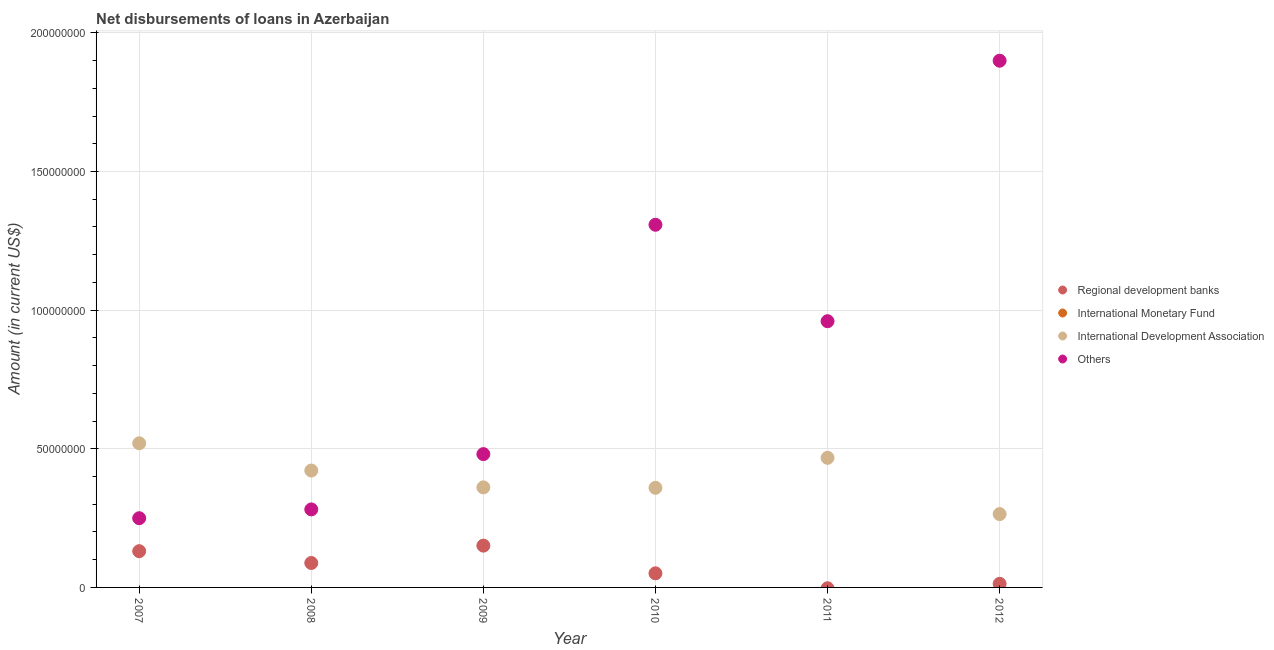What is the amount of loan disimbursed by international monetary fund in 2008?
Offer a very short reply. 0. Across all years, what is the maximum amount of loan disimbursed by regional development banks?
Ensure brevity in your answer.  1.51e+07. Across all years, what is the minimum amount of loan disimbursed by international development association?
Provide a short and direct response. 2.65e+07. In which year was the amount of loan disimbursed by international development association maximum?
Keep it short and to the point. 2007. What is the total amount of loan disimbursed by other organisations in the graph?
Your answer should be very brief. 5.18e+08. What is the difference between the amount of loan disimbursed by international development association in 2007 and that in 2009?
Provide a succinct answer. 1.59e+07. What is the difference between the amount of loan disimbursed by regional development banks in 2009 and the amount of loan disimbursed by international development association in 2008?
Offer a very short reply. -2.71e+07. What is the average amount of loan disimbursed by other organisations per year?
Give a very brief answer. 8.63e+07. In the year 2010, what is the difference between the amount of loan disimbursed by regional development banks and amount of loan disimbursed by other organisations?
Give a very brief answer. -1.26e+08. In how many years, is the amount of loan disimbursed by international monetary fund greater than 40000000 US$?
Offer a very short reply. 0. What is the ratio of the amount of loan disimbursed by international development association in 2011 to that in 2012?
Keep it short and to the point. 1.77. Is the amount of loan disimbursed by other organisations in 2010 less than that in 2011?
Offer a very short reply. No. Is the difference between the amount of loan disimbursed by other organisations in 2008 and 2009 greater than the difference between the amount of loan disimbursed by regional development banks in 2008 and 2009?
Your response must be concise. No. What is the difference between the highest and the second highest amount of loan disimbursed by international development association?
Your response must be concise. 5.24e+06. What is the difference between the highest and the lowest amount of loan disimbursed by other organisations?
Keep it short and to the point. 1.65e+08. Is the sum of the amount of loan disimbursed by regional development banks in 2008 and 2010 greater than the maximum amount of loan disimbursed by international development association across all years?
Ensure brevity in your answer.  No. Is it the case that in every year, the sum of the amount of loan disimbursed by international monetary fund and amount of loan disimbursed by other organisations is greater than the sum of amount of loan disimbursed by international development association and amount of loan disimbursed by regional development banks?
Offer a terse response. Yes. Is the amount of loan disimbursed by regional development banks strictly greater than the amount of loan disimbursed by international monetary fund over the years?
Ensure brevity in your answer.  Yes. Is the amount of loan disimbursed by international monetary fund strictly less than the amount of loan disimbursed by international development association over the years?
Your answer should be very brief. Yes. What is the difference between two consecutive major ticks on the Y-axis?
Your answer should be compact. 5.00e+07. Are the values on the major ticks of Y-axis written in scientific E-notation?
Make the answer very short. No. Does the graph contain grids?
Offer a very short reply. Yes. How many legend labels are there?
Your response must be concise. 4. What is the title of the graph?
Your answer should be very brief. Net disbursements of loans in Azerbaijan. Does "Tertiary education" appear as one of the legend labels in the graph?
Give a very brief answer. No. What is the label or title of the X-axis?
Keep it short and to the point. Year. What is the Amount (in current US$) of Regional development banks in 2007?
Your response must be concise. 1.31e+07. What is the Amount (in current US$) of International Development Association in 2007?
Provide a short and direct response. 5.20e+07. What is the Amount (in current US$) of Others in 2007?
Your answer should be very brief. 2.50e+07. What is the Amount (in current US$) in Regional development banks in 2008?
Your answer should be compact. 8.81e+06. What is the Amount (in current US$) of International Development Association in 2008?
Your answer should be compact. 4.22e+07. What is the Amount (in current US$) in Others in 2008?
Offer a very short reply. 2.81e+07. What is the Amount (in current US$) in Regional development banks in 2009?
Ensure brevity in your answer.  1.51e+07. What is the Amount (in current US$) in International Development Association in 2009?
Make the answer very short. 3.61e+07. What is the Amount (in current US$) of Others in 2009?
Offer a very short reply. 4.81e+07. What is the Amount (in current US$) in Regional development banks in 2010?
Provide a succinct answer. 5.08e+06. What is the Amount (in current US$) in International Monetary Fund in 2010?
Your response must be concise. 0. What is the Amount (in current US$) of International Development Association in 2010?
Offer a terse response. 3.59e+07. What is the Amount (in current US$) of Others in 2010?
Your answer should be compact. 1.31e+08. What is the Amount (in current US$) of Regional development banks in 2011?
Your response must be concise. 0. What is the Amount (in current US$) in International Development Association in 2011?
Offer a terse response. 4.67e+07. What is the Amount (in current US$) of Others in 2011?
Provide a succinct answer. 9.60e+07. What is the Amount (in current US$) of Regional development banks in 2012?
Offer a terse response. 1.30e+06. What is the Amount (in current US$) of International Monetary Fund in 2012?
Offer a very short reply. 0. What is the Amount (in current US$) in International Development Association in 2012?
Offer a terse response. 2.65e+07. What is the Amount (in current US$) of Others in 2012?
Provide a succinct answer. 1.90e+08. Across all years, what is the maximum Amount (in current US$) of Regional development banks?
Keep it short and to the point. 1.51e+07. Across all years, what is the maximum Amount (in current US$) in International Development Association?
Your answer should be compact. 5.20e+07. Across all years, what is the maximum Amount (in current US$) in Others?
Make the answer very short. 1.90e+08. Across all years, what is the minimum Amount (in current US$) in International Development Association?
Give a very brief answer. 2.65e+07. Across all years, what is the minimum Amount (in current US$) in Others?
Offer a very short reply. 2.50e+07. What is the total Amount (in current US$) of Regional development banks in the graph?
Your answer should be very brief. 4.33e+07. What is the total Amount (in current US$) of International Monetary Fund in the graph?
Your response must be concise. 0. What is the total Amount (in current US$) in International Development Association in the graph?
Keep it short and to the point. 2.39e+08. What is the total Amount (in current US$) in Others in the graph?
Provide a short and direct response. 5.18e+08. What is the difference between the Amount (in current US$) in Regional development banks in 2007 and that in 2008?
Keep it short and to the point. 4.26e+06. What is the difference between the Amount (in current US$) of International Development Association in 2007 and that in 2008?
Your answer should be compact. 9.82e+06. What is the difference between the Amount (in current US$) in Others in 2007 and that in 2008?
Give a very brief answer. -3.17e+06. What is the difference between the Amount (in current US$) of Regional development banks in 2007 and that in 2009?
Your response must be concise. -2.00e+06. What is the difference between the Amount (in current US$) in International Development Association in 2007 and that in 2009?
Keep it short and to the point. 1.59e+07. What is the difference between the Amount (in current US$) in Others in 2007 and that in 2009?
Make the answer very short. -2.31e+07. What is the difference between the Amount (in current US$) of Regional development banks in 2007 and that in 2010?
Ensure brevity in your answer.  7.98e+06. What is the difference between the Amount (in current US$) in International Development Association in 2007 and that in 2010?
Provide a short and direct response. 1.61e+07. What is the difference between the Amount (in current US$) of Others in 2007 and that in 2010?
Keep it short and to the point. -1.06e+08. What is the difference between the Amount (in current US$) of International Development Association in 2007 and that in 2011?
Provide a succinct answer. 5.24e+06. What is the difference between the Amount (in current US$) in Others in 2007 and that in 2011?
Your answer should be compact. -7.10e+07. What is the difference between the Amount (in current US$) of Regional development banks in 2007 and that in 2012?
Give a very brief answer. 1.18e+07. What is the difference between the Amount (in current US$) of International Development Association in 2007 and that in 2012?
Your answer should be compact. 2.55e+07. What is the difference between the Amount (in current US$) of Others in 2007 and that in 2012?
Your response must be concise. -1.65e+08. What is the difference between the Amount (in current US$) in Regional development banks in 2008 and that in 2009?
Your response must be concise. -6.26e+06. What is the difference between the Amount (in current US$) of International Development Association in 2008 and that in 2009?
Provide a short and direct response. 6.08e+06. What is the difference between the Amount (in current US$) in Others in 2008 and that in 2009?
Your answer should be very brief. -1.99e+07. What is the difference between the Amount (in current US$) in Regional development banks in 2008 and that in 2010?
Give a very brief answer. 3.73e+06. What is the difference between the Amount (in current US$) in International Development Association in 2008 and that in 2010?
Give a very brief answer. 6.23e+06. What is the difference between the Amount (in current US$) of Others in 2008 and that in 2010?
Offer a terse response. -1.03e+08. What is the difference between the Amount (in current US$) of International Development Association in 2008 and that in 2011?
Keep it short and to the point. -4.58e+06. What is the difference between the Amount (in current US$) in Others in 2008 and that in 2011?
Your response must be concise. -6.79e+07. What is the difference between the Amount (in current US$) in Regional development banks in 2008 and that in 2012?
Provide a succinct answer. 7.52e+06. What is the difference between the Amount (in current US$) in International Development Association in 2008 and that in 2012?
Give a very brief answer. 1.57e+07. What is the difference between the Amount (in current US$) in Others in 2008 and that in 2012?
Provide a succinct answer. -1.62e+08. What is the difference between the Amount (in current US$) of Regional development banks in 2009 and that in 2010?
Make the answer very short. 9.99e+06. What is the difference between the Amount (in current US$) of International Development Association in 2009 and that in 2010?
Your answer should be compact. 1.56e+05. What is the difference between the Amount (in current US$) in Others in 2009 and that in 2010?
Keep it short and to the point. -8.27e+07. What is the difference between the Amount (in current US$) of International Development Association in 2009 and that in 2011?
Offer a terse response. -1.07e+07. What is the difference between the Amount (in current US$) in Others in 2009 and that in 2011?
Ensure brevity in your answer.  -4.79e+07. What is the difference between the Amount (in current US$) in Regional development banks in 2009 and that in 2012?
Offer a terse response. 1.38e+07. What is the difference between the Amount (in current US$) of International Development Association in 2009 and that in 2012?
Make the answer very short. 9.63e+06. What is the difference between the Amount (in current US$) of Others in 2009 and that in 2012?
Provide a short and direct response. -1.42e+08. What is the difference between the Amount (in current US$) of International Development Association in 2010 and that in 2011?
Give a very brief answer. -1.08e+07. What is the difference between the Amount (in current US$) in Others in 2010 and that in 2011?
Keep it short and to the point. 3.48e+07. What is the difference between the Amount (in current US$) in Regional development banks in 2010 and that in 2012?
Your response must be concise. 3.79e+06. What is the difference between the Amount (in current US$) in International Development Association in 2010 and that in 2012?
Provide a succinct answer. 9.47e+06. What is the difference between the Amount (in current US$) in Others in 2010 and that in 2012?
Keep it short and to the point. -5.92e+07. What is the difference between the Amount (in current US$) of International Development Association in 2011 and that in 2012?
Offer a terse response. 2.03e+07. What is the difference between the Amount (in current US$) of Others in 2011 and that in 2012?
Provide a succinct answer. -9.39e+07. What is the difference between the Amount (in current US$) of Regional development banks in 2007 and the Amount (in current US$) of International Development Association in 2008?
Keep it short and to the point. -2.91e+07. What is the difference between the Amount (in current US$) in Regional development banks in 2007 and the Amount (in current US$) in Others in 2008?
Offer a terse response. -1.51e+07. What is the difference between the Amount (in current US$) of International Development Association in 2007 and the Amount (in current US$) of Others in 2008?
Ensure brevity in your answer.  2.38e+07. What is the difference between the Amount (in current US$) in Regional development banks in 2007 and the Amount (in current US$) in International Development Association in 2009?
Provide a short and direct response. -2.30e+07. What is the difference between the Amount (in current US$) of Regional development banks in 2007 and the Amount (in current US$) of Others in 2009?
Keep it short and to the point. -3.50e+07. What is the difference between the Amount (in current US$) of International Development Association in 2007 and the Amount (in current US$) of Others in 2009?
Provide a succinct answer. 3.90e+06. What is the difference between the Amount (in current US$) in Regional development banks in 2007 and the Amount (in current US$) in International Development Association in 2010?
Your answer should be very brief. -2.29e+07. What is the difference between the Amount (in current US$) in Regional development banks in 2007 and the Amount (in current US$) in Others in 2010?
Make the answer very short. -1.18e+08. What is the difference between the Amount (in current US$) in International Development Association in 2007 and the Amount (in current US$) in Others in 2010?
Provide a succinct answer. -7.88e+07. What is the difference between the Amount (in current US$) of Regional development banks in 2007 and the Amount (in current US$) of International Development Association in 2011?
Your answer should be very brief. -3.37e+07. What is the difference between the Amount (in current US$) in Regional development banks in 2007 and the Amount (in current US$) in Others in 2011?
Make the answer very short. -8.29e+07. What is the difference between the Amount (in current US$) in International Development Association in 2007 and the Amount (in current US$) in Others in 2011?
Provide a succinct answer. -4.40e+07. What is the difference between the Amount (in current US$) of Regional development banks in 2007 and the Amount (in current US$) of International Development Association in 2012?
Ensure brevity in your answer.  -1.34e+07. What is the difference between the Amount (in current US$) of Regional development banks in 2007 and the Amount (in current US$) of Others in 2012?
Provide a short and direct response. -1.77e+08. What is the difference between the Amount (in current US$) of International Development Association in 2007 and the Amount (in current US$) of Others in 2012?
Provide a short and direct response. -1.38e+08. What is the difference between the Amount (in current US$) in Regional development banks in 2008 and the Amount (in current US$) in International Development Association in 2009?
Provide a succinct answer. -2.73e+07. What is the difference between the Amount (in current US$) of Regional development banks in 2008 and the Amount (in current US$) of Others in 2009?
Keep it short and to the point. -3.93e+07. What is the difference between the Amount (in current US$) of International Development Association in 2008 and the Amount (in current US$) of Others in 2009?
Give a very brief answer. -5.92e+06. What is the difference between the Amount (in current US$) of Regional development banks in 2008 and the Amount (in current US$) of International Development Association in 2010?
Your answer should be very brief. -2.71e+07. What is the difference between the Amount (in current US$) of Regional development banks in 2008 and the Amount (in current US$) of Others in 2010?
Offer a terse response. -1.22e+08. What is the difference between the Amount (in current US$) of International Development Association in 2008 and the Amount (in current US$) of Others in 2010?
Your answer should be compact. -8.86e+07. What is the difference between the Amount (in current US$) in Regional development banks in 2008 and the Amount (in current US$) in International Development Association in 2011?
Ensure brevity in your answer.  -3.79e+07. What is the difference between the Amount (in current US$) of Regional development banks in 2008 and the Amount (in current US$) of Others in 2011?
Your answer should be compact. -8.72e+07. What is the difference between the Amount (in current US$) of International Development Association in 2008 and the Amount (in current US$) of Others in 2011?
Ensure brevity in your answer.  -5.39e+07. What is the difference between the Amount (in current US$) in Regional development banks in 2008 and the Amount (in current US$) in International Development Association in 2012?
Your answer should be very brief. -1.76e+07. What is the difference between the Amount (in current US$) of Regional development banks in 2008 and the Amount (in current US$) of Others in 2012?
Keep it short and to the point. -1.81e+08. What is the difference between the Amount (in current US$) of International Development Association in 2008 and the Amount (in current US$) of Others in 2012?
Offer a very short reply. -1.48e+08. What is the difference between the Amount (in current US$) in Regional development banks in 2009 and the Amount (in current US$) in International Development Association in 2010?
Keep it short and to the point. -2.09e+07. What is the difference between the Amount (in current US$) in Regional development banks in 2009 and the Amount (in current US$) in Others in 2010?
Your response must be concise. -1.16e+08. What is the difference between the Amount (in current US$) of International Development Association in 2009 and the Amount (in current US$) of Others in 2010?
Give a very brief answer. -9.47e+07. What is the difference between the Amount (in current US$) in Regional development banks in 2009 and the Amount (in current US$) in International Development Association in 2011?
Ensure brevity in your answer.  -3.17e+07. What is the difference between the Amount (in current US$) in Regional development banks in 2009 and the Amount (in current US$) in Others in 2011?
Ensure brevity in your answer.  -8.09e+07. What is the difference between the Amount (in current US$) of International Development Association in 2009 and the Amount (in current US$) of Others in 2011?
Make the answer very short. -5.99e+07. What is the difference between the Amount (in current US$) in Regional development banks in 2009 and the Amount (in current US$) in International Development Association in 2012?
Provide a short and direct response. -1.14e+07. What is the difference between the Amount (in current US$) in Regional development banks in 2009 and the Amount (in current US$) in Others in 2012?
Provide a short and direct response. -1.75e+08. What is the difference between the Amount (in current US$) of International Development Association in 2009 and the Amount (in current US$) of Others in 2012?
Your answer should be compact. -1.54e+08. What is the difference between the Amount (in current US$) in Regional development banks in 2010 and the Amount (in current US$) in International Development Association in 2011?
Give a very brief answer. -4.17e+07. What is the difference between the Amount (in current US$) in Regional development banks in 2010 and the Amount (in current US$) in Others in 2011?
Provide a succinct answer. -9.09e+07. What is the difference between the Amount (in current US$) of International Development Association in 2010 and the Amount (in current US$) of Others in 2011?
Your response must be concise. -6.01e+07. What is the difference between the Amount (in current US$) in Regional development banks in 2010 and the Amount (in current US$) in International Development Association in 2012?
Keep it short and to the point. -2.14e+07. What is the difference between the Amount (in current US$) of Regional development banks in 2010 and the Amount (in current US$) of Others in 2012?
Your answer should be very brief. -1.85e+08. What is the difference between the Amount (in current US$) in International Development Association in 2010 and the Amount (in current US$) in Others in 2012?
Your answer should be very brief. -1.54e+08. What is the difference between the Amount (in current US$) in International Development Association in 2011 and the Amount (in current US$) in Others in 2012?
Your answer should be very brief. -1.43e+08. What is the average Amount (in current US$) in Regional development banks per year?
Your answer should be compact. 7.22e+06. What is the average Amount (in current US$) of International Monetary Fund per year?
Your response must be concise. 0. What is the average Amount (in current US$) in International Development Association per year?
Offer a very short reply. 3.99e+07. What is the average Amount (in current US$) in Others per year?
Provide a short and direct response. 8.63e+07. In the year 2007, what is the difference between the Amount (in current US$) of Regional development banks and Amount (in current US$) of International Development Association?
Give a very brief answer. -3.89e+07. In the year 2007, what is the difference between the Amount (in current US$) in Regional development banks and Amount (in current US$) in Others?
Your answer should be very brief. -1.19e+07. In the year 2007, what is the difference between the Amount (in current US$) of International Development Association and Amount (in current US$) of Others?
Provide a short and direct response. 2.70e+07. In the year 2008, what is the difference between the Amount (in current US$) of Regional development banks and Amount (in current US$) of International Development Association?
Keep it short and to the point. -3.33e+07. In the year 2008, what is the difference between the Amount (in current US$) in Regional development banks and Amount (in current US$) in Others?
Your answer should be very brief. -1.93e+07. In the year 2008, what is the difference between the Amount (in current US$) of International Development Association and Amount (in current US$) of Others?
Offer a terse response. 1.40e+07. In the year 2009, what is the difference between the Amount (in current US$) in Regional development banks and Amount (in current US$) in International Development Association?
Provide a short and direct response. -2.10e+07. In the year 2009, what is the difference between the Amount (in current US$) of Regional development banks and Amount (in current US$) of Others?
Your answer should be compact. -3.30e+07. In the year 2009, what is the difference between the Amount (in current US$) of International Development Association and Amount (in current US$) of Others?
Make the answer very short. -1.20e+07. In the year 2010, what is the difference between the Amount (in current US$) of Regional development banks and Amount (in current US$) of International Development Association?
Your response must be concise. -3.08e+07. In the year 2010, what is the difference between the Amount (in current US$) of Regional development banks and Amount (in current US$) of Others?
Provide a succinct answer. -1.26e+08. In the year 2010, what is the difference between the Amount (in current US$) of International Development Association and Amount (in current US$) of Others?
Your response must be concise. -9.49e+07. In the year 2011, what is the difference between the Amount (in current US$) of International Development Association and Amount (in current US$) of Others?
Offer a very short reply. -4.93e+07. In the year 2012, what is the difference between the Amount (in current US$) in Regional development banks and Amount (in current US$) in International Development Association?
Your answer should be compact. -2.52e+07. In the year 2012, what is the difference between the Amount (in current US$) of Regional development banks and Amount (in current US$) of Others?
Give a very brief answer. -1.89e+08. In the year 2012, what is the difference between the Amount (in current US$) of International Development Association and Amount (in current US$) of Others?
Make the answer very short. -1.64e+08. What is the ratio of the Amount (in current US$) in Regional development banks in 2007 to that in 2008?
Provide a short and direct response. 1.48. What is the ratio of the Amount (in current US$) of International Development Association in 2007 to that in 2008?
Your answer should be compact. 1.23. What is the ratio of the Amount (in current US$) of Others in 2007 to that in 2008?
Provide a short and direct response. 0.89. What is the ratio of the Amount (in current US$) in Regional development banks in 2007 to that in 2009?
Provide a short and direct response. 0.87. What is the ratio of the Amount (in current US$) of International Development Association in 2007 to that in 2009?
Your answer should be very brief. 1.44. What is the ratio of the Amount (in current US$) in Others in 2007 to that in 2009?
Ensure brevity in your answer.  0.52. What is the ratio of the Amount (in current US$) in Regional development banks in 2007 to that in 2010?
Your answer should be very brief. 2.57. What is the ratio of the Amount (in current US$) in International Development Association in 2007 to that in 2010?
Provide a short and direct response. 1.45. What is the ratio of the Amount (in current US$) in Others in 2007 to that in 2010?
Ensure brevity in your answer.  0.19. What is the ratio of the Amount (in current US$) of International Development Association in 2007 to that in 2011?
Ensure brevity in your answer.  1.11. What is the ratio of the Amount (in current US$) in Others in 2007 to that in 2011?
Ensure brevity in your answer.  0.26. What is the ratio of the Amount (in current US$) in Regional development banks in 2007 to that in 2012?
Offer a very short reply. 10.08. What is the ratio of the Amount (in current US$) in International Development Association in 2007 to that in 2012?
Give a very brief answer. 1.97. What is the ratio of the Amount (in current US$) in Others in 2007 to that in 2012?
Ensure brevity in your answer.  0.13. What is the ratio of the Amount (in current US$) of Regional development banks in 2008 to that in 2009?
Provide a short and direct response. 0.58. What is the ratio of the Amount (in current US$) in International Development Association in 2008 to that in 2009?
Keep it short and to the point. 1.17. What is the ratio of the Amount (in current US$) in Others in 2008 to that in 2009?
Keep it short and to the point. 0.59. What is the ratio of the Amount (in current US$) in Regional development banks in 2008 to that in 2010?
Ensure brevity in your answer.  1.73. What is the ratio of the Amount (in current US$) in International Development Association in 2008 to that in 2010?
Ensure brevity in your answer.  1.17. What is the ratio of the Amount (in current US$) in Others in 2008 to that in 2010?
Your answer should be very brief. 0.22. What is the ratio of the Amount (in current US$) in International Development Association in 2008 to that in 2011?
Your answer should be compact. 0.9. What is the ratio of the Amount (in current US$) of Others in 2008 to that in 2011?
Make the answer very short. 0.29. What is the ratio of the Amount (in current US$) in Regional development banks in 2008 to that in 2012?
Provide a succinct answer. 6.8. What is the ratio of the Amount (in current US$) of International Development Association in 2008 to that in 2012?
Offer a terse response. 1.59. What is the ratio of the Amount (in current US$) in Others in 2008 to that in 2012?
Your response must be concise. 0.15. What is the ratio of the Amount (in current US$) of Regional development banks in 2009 to that in 2010?
Make the answer very short. 2.96. What is the ratio of the Amount (in current US$) in International Development Association in 2009 to that in 2010?
Keep it short and to the point. 1. What is the ratio of the Amount (in current US$) in Others in 2009 to that in 2010?
Make the answer very short. 0.37. What is the ratio of the Amount (in current US$) of International Development Association in 2009 to that in 2011?
Provide a short and direct response. 0.77. What is the ratio of the Amount (in current US$) of Others in 2009 to that in 2011?
Provide a succinct answer. 0.5. What is the ratio of the Amount (in current US$) of Regional development banks in 2009 to that in 2012?
Your answer should be compact. 11.62. What is the ratio of the Amount (in current US$) of International Development Association in 2009 to that in 2012?
Provide a succinct answer. 1.36. What is the ratio of the Amount (in current US$) in Others in 2009 to that in 2012?
Keep it short and to the point. 0.25. What is the ratio of the Amount (in current US$) in International Development Association in 2010 to that in 2011?
Provide a short and direct response. 0.77. What is the ratio of the Amount (in current US$) of Others in 2010 to that in 2011?
Your answer should be compact. 1.36. What is the ratio of the Amount (in current US$) in Regional development banks in 2010 to that in 2012?
Provide a succinct answer. 3.92. What is the ratio of the Amount (in current US$) in International Development Association in 2010 to that in 2012?
Ensure brevity in your answer.  1.36. What is the ratio of the Amount (in current US$) in Others in 2010 to that in 2012?
Offer a very short reply. 0.69. What is the ratio of the Amount (in current US$) in International Development Association in 2011 to that in 2012?
Provide a succinct answer. 1.77. What is the ratio of the Amount (in current US$) of Others in 2011 to that in 2012?
Offer a terse response. 0.51. What is the difference between the highest and the second highest Amount (in current US$) of Regional development banks?
Offer a very short reply. 2.00e+06. What is the difference between the highest and the second highest Amount (in current US$) in International Development Association?
Keep it short and to the point. 5.24e+06. What is the difference between the highest and the second highest Amount (in current US$) of Others?
Your answer should be compact. 5.92e+07. What is the difference between the highest and the lowest Amount (in current US$) of Regional development banks?
Make the answer very short. 1.51e+07. What is the difference between the highest and the lowest Amount (in current US$) of International Development Association?
Ensure brevity in your answer.  2.55e+07. What is the difference between the highest and the lowest Amount (in current US$) of Others?
Ensure brevity in your answer.  1.65e+08. 